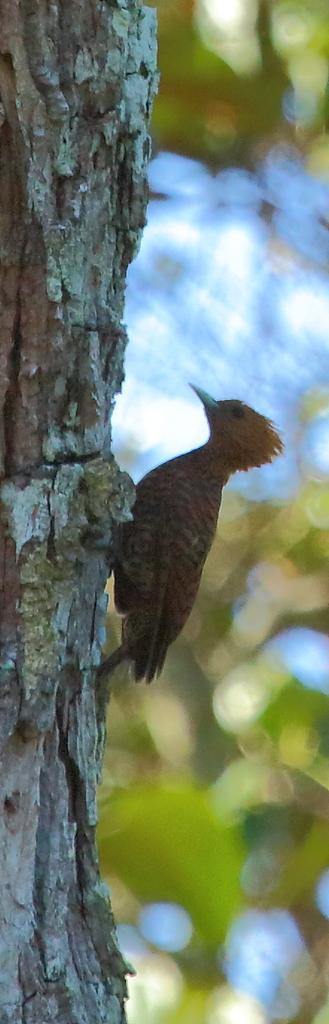Can you describe this image briefly? In this picture we can see a bird on a tree trunk. In the background of the image it is blurry. 